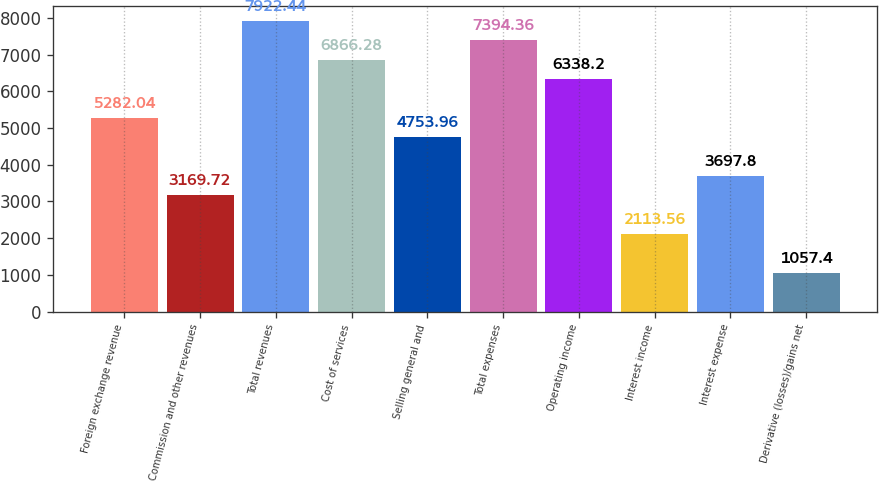<chart> <loc_0><loc_0><loc_500><loc_500><bar_chart><fcel>Foreign exchange revenue<fcel>Commission and other revenues<fcel>Total revenues<fcel>Cost of services<fcel>Selling general and<fcel>Total expenses<fcel>Operating income<fcel>Interest income<fcel>Interest expense<fcel>Derivative (losses)/gains net<nl><fcel>5282.04<fcel>3169.72<fcel>7922.44<fcel>6866.28<fcel>4753.96<fcel>7394.36<fcel>6338.2<fcel>2113.56<fcel>3697.8<fcel>1057.4<nl></chart> 